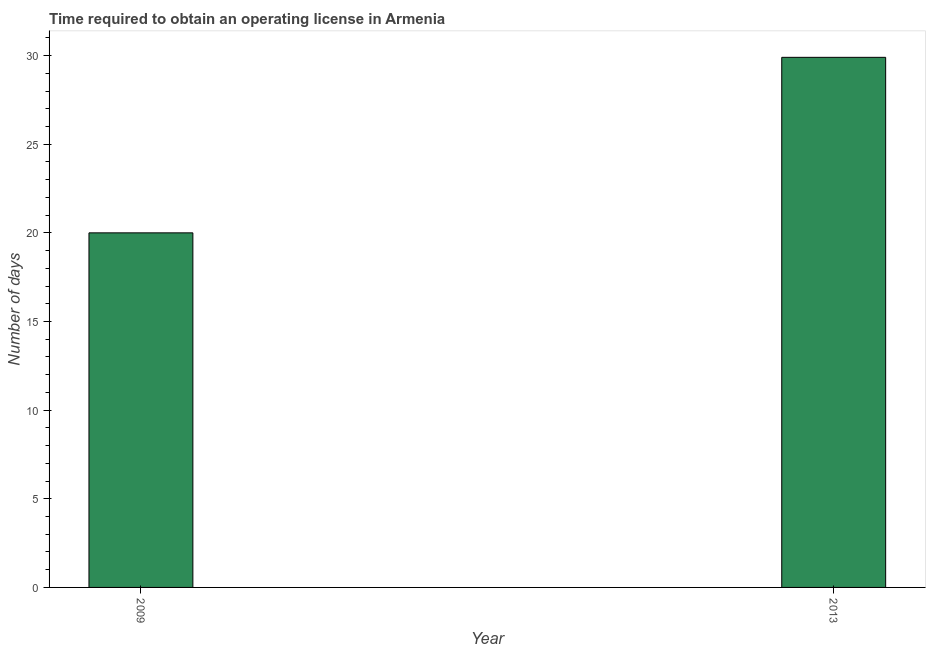What is the title of the graph?
Ensure brevity in your answer.  Time required to obtain an operating license in Armenia. What is the label or title of the Y-axis?
Provide a short and direct response. Number of days. Across all years, what is the maximum number of days to obtain operating license?
Keep it short and to the point. 29.9. In which year was the number of days to obtain operating license maximum?
Your answer should be compact. 2013. In which year was the number of days to obtain operating license minimum?
Your response must be concise. 2009. What is the sum of the number of days to obtain operating license?
Offer a terse response. 49.9. What is the difference between the number of days to obtain operating license in 2009 and 2013?
Your answer should be very brief. -9.9. What is the average number of days to obtain operating license per year?
Offer a terse response. 24.95. What is the median number of days to obtain operating license?
Your response must be concise. 24.95. In how many years, is the number of days to obtain operating license greater than 20 days?
Your answer should be very brief. 1. Do a majority of the years between 2009 and 2013 (inclusive) have number of days to obtain operating license greater than 26 days?
Offer a terse response. No. What is the ratio of the number of days to obtain operating license in 2009 to that in 2013?
Give a very brief answer. 0.67. Is the number of days to obtain operating license in 2009 less than that in 2013?
Your answer should be compact. Yes. How many years are there in the graph?
Your answer should be compact. 2. Are the values on the major ticks of Y-axis written in scientific E-notation?
Your answer should be compact. No. What is the Number of days of 2009?
Offer a terse response. 20. What is the Number of days in 2013?
Offer a very short reply. 29.9. What is the difference between the Number of days in 2009 and 2013?
Ensure brevity in your answer.  -9.9. What is the ratio of the Number of days in 2009 to that in 2013?
Provide a succinct answer. 0.67. 